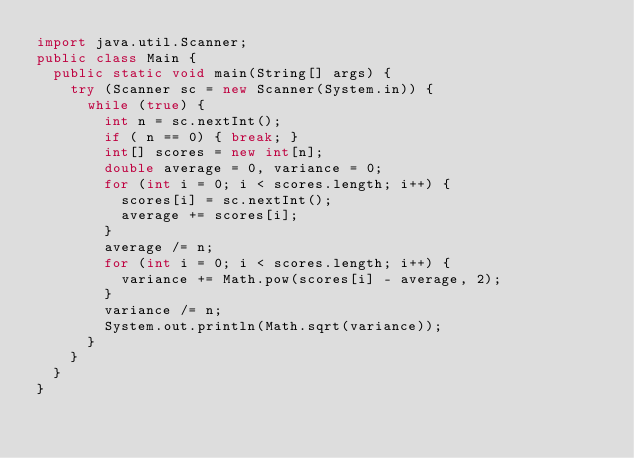<code> <loc_0><loc_0><loc_500><loc_500><_Java_>import java.util.Scanner;
public class Main {
  public static void main(String[] args) {
    try (Scanner sc = new Scanner(System.in)) {
      while (true) {
        int n = sc.nextInt();
        if ( n == 0) { break; }
        int[] scores = new int[n];
        double average = 0, variance = 0;
        for (int i = 0; i < scores.length; i++) {
          scores[i] = sc.nextInt();
          average += scores[i];
        }
        average /= n;
        for (int i = 0; i < scores.length; i++) {
          variance += Math.pow(scores[i] - average, 2);
        }
        variance /= n;
        System.out.println(Math.sqrt(variance));
      }
    }
  }
}

</code> 